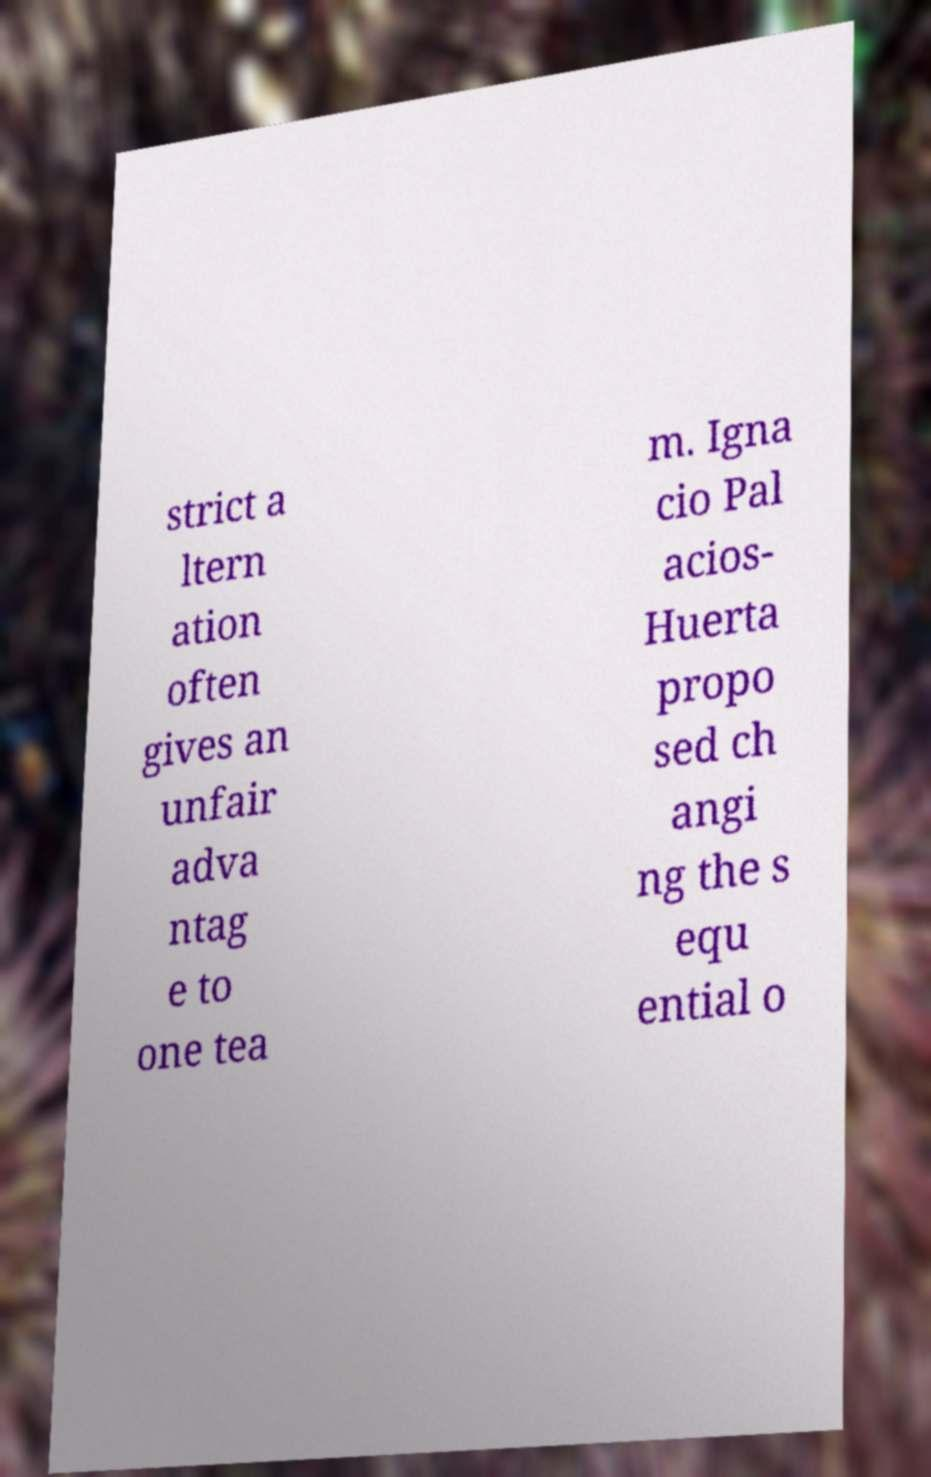Could you extract and type out the text from this image? strict a ltern ation often gives an unfair adva ntag e to one tea m. Igna cio Pal acios- Huerta propo sed ch angi ng the s equ ential o 